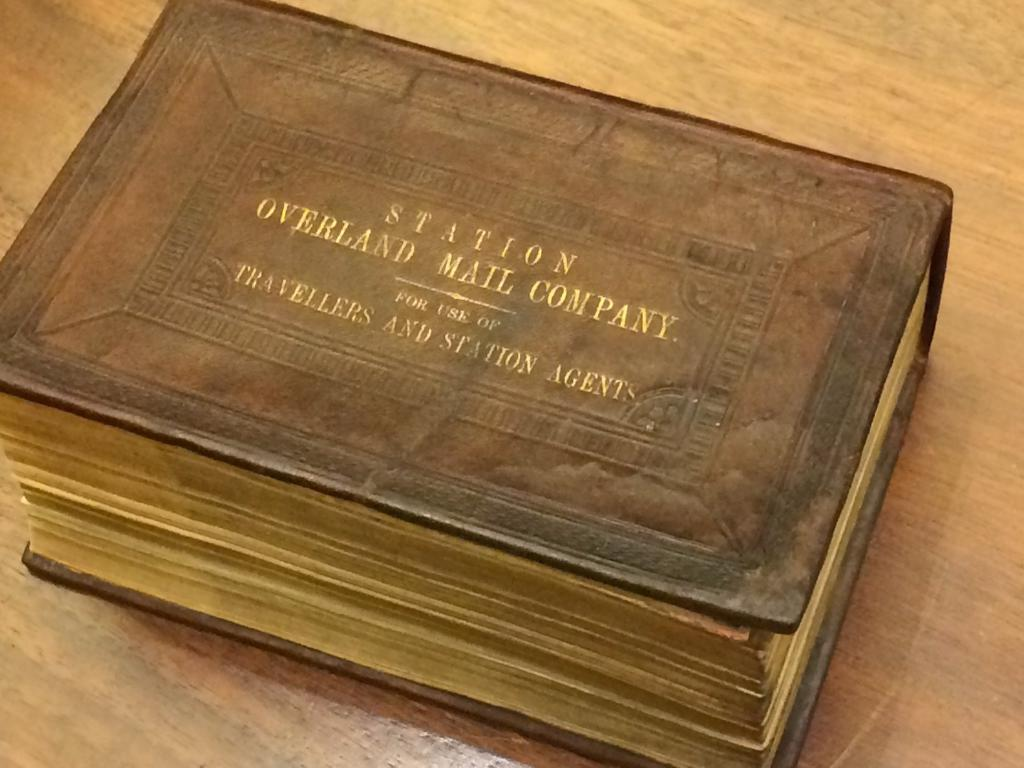Provide a one-sentence caption for the provided image. An old leatherbound ledger reads "Station Overland Mail Company, For Use Of Travellers and Station Agents" on the cover. 